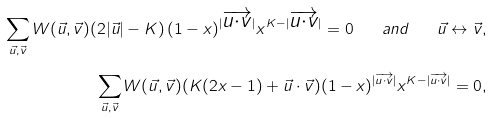Convert formula to latex. <formula><loc_0><loc_0><loc_500><loc_500>\sum _ { \vec { u } , \vec { v } } W ( \vec { u } , \vec { v } ) ( 2 | \vec { u } | - K ) \, ( 1 - x ) ^ { | \overrightarrow { u \cdot v } | } x ^ { K - | \overrightarrow { u \cdot v } | } = 0 \quad a n d \quad \vec { u } \leftrightarrow \vec { v } , \\ \sum _ { \vec { u } , \vec { v } } W ( \vec { u } , \vec { v } ) ( K ( 2 x - 1 ) + \vec { u } \cdot \vec { v } ) ( 1 - x ) ^ { | \overrightarrow { u \cdot v } | } x ^ { K - | \overrightarrow { u \cdot v } | } = 0 ,</formula> 